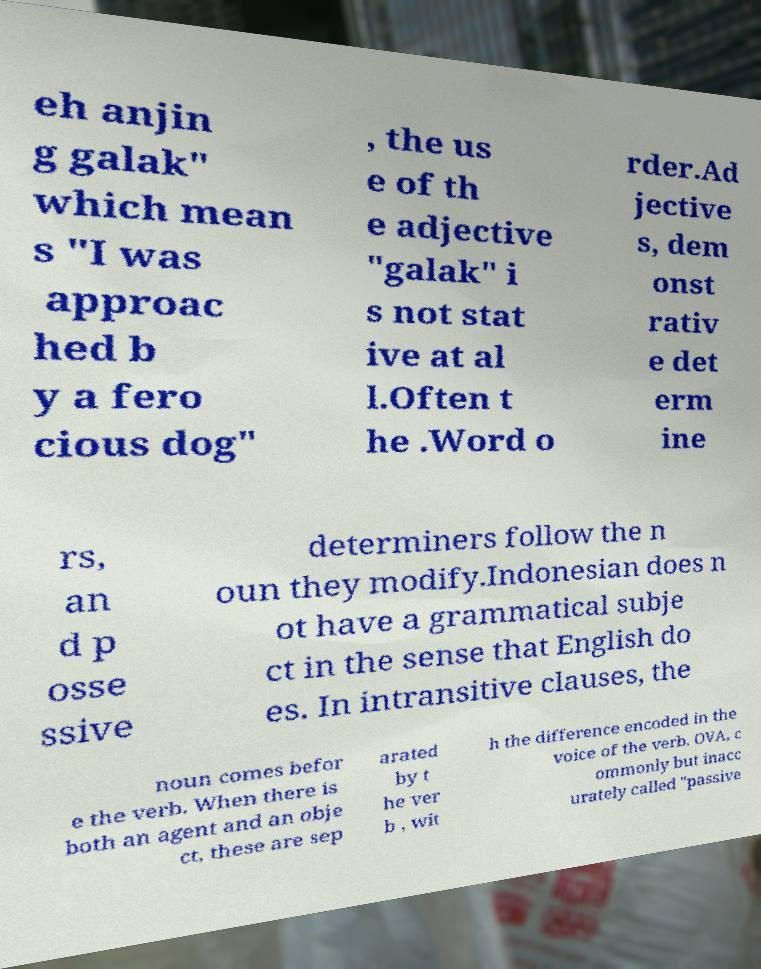Please identify and transcribe the text found in this image. eh anjin g galak" which mean s "I was approac hed b y a fero cious dog" , the us e of th e adjective "galak" i s not stat ive at al l.Often t he .Word o rder.Ad jective s, dem onst rativ e det erm ine rs, an d p osse ssive determiners follow the n oun they modify.Indonesian does n ot have a grammatical subje ct in the sense that English do es. In intransitive clauses, the noun comes befor e the verb. When there is both an agent and an obje ct, these are sep arated by t he ver b , wit h the difference encoded in the voice of the verb. OVA, c ommonly but inacc urately called "passive 